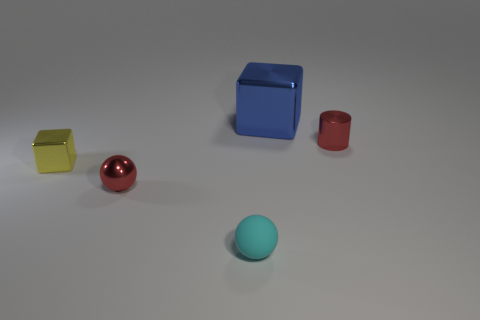Subtract all cylinders. How many objects are left? 4 Subtract 1 blocks. How many blocks are left? 1 Subtract all gray balls. How many brown cylinders are left? 0 Subtract all blue shiny blocks. Subtract all red shiny objects. How many objects are left? 2 Add 1 small metal spheres. How many small metal spheres are left? 2 Add 1 blue spheres. How many blue spheres exist? 1 Add 1 tiny red metallic spheres. How many objects exist? 6 Subtract all red spheres. How many spheres are left? 1 Subtract 0 purple cylinders. How many objects are left? 5 Subtract all purple cubes. Subtract all green cylinders. How many cubes are left? 2 